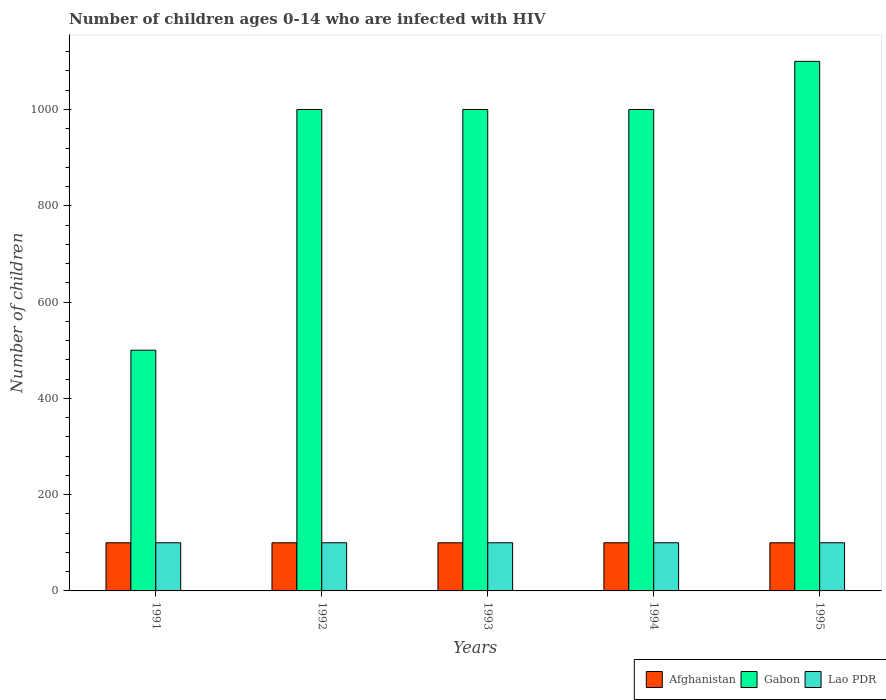How many different coloured bars are there?
Offer a very short reply. 3. How many groups of bars are there?
Your answer should be very brief. 5. How many bars are there on the 3rd tick from the left?
Offer a very short reply. 3. How many bars are there on the 1st tick from the right?
Your answer should be compact. 3. What is the number of HIV infected children in Lao PDR in 1994?
Your answer should be very brief. 100. Across all years, what is the maximum number of HIV infected children in Gabon?
Provide a short and direct response. 1100. Across all years, what is the minimum number of HIV infected children in Afghanistan?
Offer a very short reply. 100. In which year was the number of HIV infected children in Afghanistan maximum?
Make the answer very short. 1991. What is the total number of HIV infected children in Gabon in the graph?
Give a very brief answer. 4600. What is the difference between the number of HIV infected children in Gabon in 1992 and the number of HIV infected children in Lao PDR in 1991?
Your answer should be compact. 900. What is the average number of HIV infected children in Gabon per year?
Make the answer very short. 920. In the year 1991, what is the difference between the number of HIV infected children in Afghanistan and number of HIV infected children in Lao PDR?
Offer a very short reply. 0. In how many years, is the number of HIV infected children in Gabon greater than 920?
Ensure brevity in your answer.  4. What is the ratio of the number of HIV infected children in Lao PDR in 1992 to that in 1995?
Offer a very short reply. 1. Is the number of HIV infected children in Lao PDR in 1994 less than that in 1995?
Give a very brief answer. No. Is the difference between the number of HIV infected children in Afghanistan in 1992 and 1994 greater than the difference between the number of HIV infected children in Lao PDR in 1992 and 1994?
Your answer should be compact. No. In how many years, is the number of HIV infected children in Gabon greater than the average number of HIV infected children in Gabon taken over all years?
Give a very brief answer. 4. Is the sum of the number of HIV infected children in Lao PDR in 1993 and 1995 greater than the maximum number of HIV infected children in Afghanistan across all years?
Offer a terse response. Yes. What does the 3rd bar from the left in 1994 represents?
Give a very brief answer. Lao PDR. What does the 2nd bar from the right in 1993 represents?
Provide a succinct answer. Gabon. How many bars are there?
Ensure brevity in your answer.  15. What is the difference between two consecutive major ticks on the Y-axis?
Give a very brief answer. 200. Are the values on the major ticks of Y-axis written in scientific E-notation?
Offer a very short reply. No. How many legend labels are there?
Keep it short and to the point. 3. How are the legend labels stacked?
Provide a short and direct response. Horizontal. What is the title of the graph?
Your answer should be very brief. Number of children ages 0-14 who are infected with HIV. Does "Burkina Faso" appear as one of the legend labels in the graph?
Your answer should be compact. No. What is the label or title of the Y-axis?
Provide a short and direct response. Number of children. What is the Number of children in Afghanistan in 1991?
Your answer should be compact. 100. What is the Number of children in Gabon in 1991?
Offer a terse response. 500. What is the Number of children in Lao PDR in 1991?
Provide a short and direct response. 100. What is the Number of children of Gabon in 1992?
Give a very brief answer. 1000. What is the Number of children in Gabon in 1993?
Keep it short and to the point. 1000. What is the Number of children in Afghanistan in 1994?
Your response must be concise. 100. What is the Number of children of Gabon in 1994?
Your answer should be compact. 1000. What is the Number of children in Lao PDR in 1994?
Your response must be concise. 100. What is the Number of children of Afghanistan in 1995?
Keep it short and to the point. 100. What is the Number of children in Gabon in 1995?
Make the answer very short. 1100. Across all years, what is the maximum Number of children of Gabon?
Make the answer very short. 1100. Across all years, what is the minimum Number of children in Afghanistan?
Ensure brevity in your answer.  100. What is the total Number of children in Gabon in the graph?
Make the answer very short. 4600. What is the difference between the Number of children in Gabon in 1991 and that in 1992?
Ensure brevity in your answer.  -500. What is the difference between the Number of children in Gabon in 1991 and that in 1993?
Your answer should be very brief. -500. What is the difference between the Number of children in Afghanistan in 1991 and that in 1994?
Ensure brevity in your answer.  0. What is the difference between the Number of children in Gabon in 1991 and that in 1994?
Give a very brief answer. -500. What is the difference between the Number of children in Lao PDR in 1991 and that in 1994?
Your response must be concise. 0. What is the difference between the Number of children of Afghanistan in 1991 and that in 1995?
Keep it short and to the point. 0. What is the difference between the Number of children of Gabon in 1991 and that in 1995?
Your answer should be very brief. -600. What is the difference between the Number of children in Afghanistan in 1992 and that in 1993?
Keep it short and to the point. 0. What is the difference between the Number of children in Lao PDR in 1992 and that in 1993?
Provide a short and direct response. 0. What is the difference between the Number of children of Gabon in 1992 and that in 1994?
Ensure brevity in your answer.  0. What is the difference between the Number of children of Gabon in 1992 and that in 1995?
Provide a short and direct response. -100. What is the difference between the Number of children in Gabon in 1993 and that in 1994?
Your response must be concise. 0. What is the difference between the Number of children in Lao PDR in 1993 and that in 1994?
Give a very brief answer. 0. What is the difference between the Number of children of Afghanistan in 1993 and that in 1995?
Provide a succinct answer. 0. What is the difference between the Number of children in Gabon in 1993 and that in 1995?
Give a very brief answer. -100. What is the difference between the Number of children in Lao PDR in 1993 and that in 1995?
Provide a succinct answer. 0. What is the difference between the Number of children in Afghanistan in 1994 and that in 1995?
Offer a terse response. 0. What is the difference between the Number of children of Gabon in 1994 and that in 1995?
Your answer should be compact. -100. What is the difference between the Number of children of Lao PDR in 1994 and that in 1995?
Ensure brevity in your answer.  0. What is the difference between the Number of children of Afghanistan in 1991 and the Number of children of Gabon in 1992?
Provide a succinct answer. -900. What is the difference between the Number of children of Gabon in 1991 and the Number of children of Lao PDR in 1992?
Keep it short and to the point. 400. What is the difference between the Number of children in Afghanistan in 1991 and the Number of children in Gabon in 1993?
Your answer should be very brief. -900. What is the difference between the Number of children of Afghanistan in 1991 and the Number of children of Lao PDR in 1993?
Offer a terse response. 0. What is the difference between the Number of children in Afghanistan in 1991 and the Number of children in Gabon in 1994?
Give a very brief answer. -900. What is the difference between the Number of children in Afghanistan in 1991 and the Number of children in Lao PDR in 1994?
Give a very brief answer. 0. What is the difference between the Number of children in Afghanistan in 1991 and the Number of children in Gabon in 1995?
Keep it short and to the point. -1000. What is the difference between the Number of children in Afghanistan in 1991 and the Number of children in Lao PDR in 1995?
Your answer should be compact. 0. What is the difference between the Number of children in Afghanistan in 1992 and the Number of children in Gabon in 1993?
Ensure brevity in your answer.  -900. What is the difference between the Number of children in Gabon in 1992 and the Number of children in Lao PDR in 1993?
Provide a short and direct response. 900. What is the difference between the Number of children of Afghanistan in 1992 and the Number of children of Gabon in 1994?
Give a very brief answer. -900. What is the difference between the Number of children of Gabon in 1992 and the Number of children of Lao PDR in 1994?
Your answer should be very brief. 900. What is the difference between the Number of children of Afghanistan in 1992 and the Number of children of Gabon in 1995?
Keep it short and to the point. -1000. What is the difference between the Number of children of Afghanistan in 1992 and the Number of children of Lao PDR in 1995?
Ensure brevity in your answer.  0. What is the difference between the Number of children of Gabon in 1992 and the Number of children of Lao PDR in 1995?
Your answer should be very brief. 900. What is the difference between the Number of children of Afghanistan in 1993 and the Number of children of Gabon in 1994?
Offer a terse response. -900. What is the difference between the Number of children of Afghanistan in 1993 and the Number of children of Lao PDR in 1994?
Provide a short and direct response. 0. What is the difference between the Number of children of Gabon in 1993 and the Number of children of Lao PDR in 1994?
Your response must be concise. 900. What is the difference between the Number of children of Afghanistan in 1993 and the Number of children of Gabon in 1995?
Your answer should be compact. -1000. What is the difference between the Number of children in Gabon in 1993 and the Number of children in Lao PDR in 1995?
Offer a terse response. 900. What is the difference between the Number of children of Afghanistan in 1994 and the Number of children of Gabon in 1995?
Ensure brevity in your answer.  -1000. What is the difference between the Number of children in Gabon in 1994 and the Number of children in Lao PDR in 1995?
Make the answer very short. 900. What is the average Number of children of Gabon per year?
Give a very brief answer. 920. In the year 1991, what is the difference between the Number of children in Afghanistan and Number of children in Gabon?
Your answer should be very brief. -400. In the year 1991, what is the difference between the Number of children of Afghanistan and Number of children of Lao PDR?
Provide a succinct answer. 0. In the year 1992, what is the difference between the Number of children in Afghanistan and Number of children in Gabon?
Your answer should be very brief. -900. In the year 1992, what is the difference between the Number of children of Gabon and Number of children of Lao PDR?
Offer a very short reply. 900. In the year 1993, what is the difference between the Number of children in Afghanistan and Number of children in Gabon?
Make the answer very short. -900. In the year 1993, what is the difference between the Number of children of Afghanistan and Number of children of Lao PDR?
Provide a succinct answer. 0. In the year 1993, what is the difference between the Number of children in Gabon and Number of children in Lao PDR?
Give a very brief answer. 900. In the year 1994, what is the difference between the Number of children of Afghanistan and Number of children of Gabon?
Give a very brief answer. -900. In the year 1994, what is the difference between the Number of children of Afghanistan and Number of children of Lao PDR?
Ensure brevity in your answer.  0. In the year 1994, what is the difference between the Number of children in Gabon and Number of children in Lao PDR?
Give a very brief answer. 900. In the year 1995, what is the difference between the Number of children in Afghanistan and Number of children in Gabon?
Your answer should be compact. -1000. In the year 1995, what is the difference between the Number of children in Gabon and Number of children in Lao PDR?
Provide a succinct answer. 1000. What is the ratio of the Number of children of Afghanistan in 1991 to that in 1992?
Offer a terse response. 1. What is the ratio of the Number of children of Afghanistan in 1991 to that in 1994?
Provide a succinct answer. 1. What is the ratio of the Number of children in Gabon in 1991 to that in 1994?
Your answer should be compact. 0.5. What is the ratio of the Number of children of Afghanistan in 1991 to that in 1995?
Make the answer very short. 1. What is the ratio of the Number of children of Gabon in 1991 to that in 1995?
Your response must be concise. 0.45. What is the ratio of the Number of children in Lao PDR in 1991 to that in 1995?
Your answer should be compact. 1. What is the ratio of the Number of children of Afghanistan in 1992 to that in 1993?
Keep it short and to the point. 1. What is the ratio of the Number of children in Lao PDR in 1992 to that in 1993?
Keep it short and to the point. 1. What is the ratio of the Number of children of Gabon in 1992 to that in 1994?
Keep it short and to the point. 1. What is the ratio of the Number of children in Gabon in 1992 to that in 1995?
Give a very brief answer. 0.91. What is the ratio of the Number of children in Lao PDR in 1992 to that in 1995?
Ensure brevity in your answer.  1. What is the ratio of the Number of children of Gabon in 1993 to that in 1994?
Ensure brevity in your answer.  1. What is the ratio of the Number of children of Afghanistan in 1993 to that in 1995?
Keep it short and to the point. 1. What is the ratio of the Number of children of Gabon in 1993 to that in 1995?
Your answer should be compact. 0.91. What is the ratio of the Number of children of Afghanistan in 1994 to that in 1995?
Make the answer very short. 1. What is the difference between the highest and the lowest Number of children in Afghanistan?
Provide a short and direct response. 0. What is the difference between the highest and the lowest Number of children in Gabon?
Your answer should be compact. 600. 